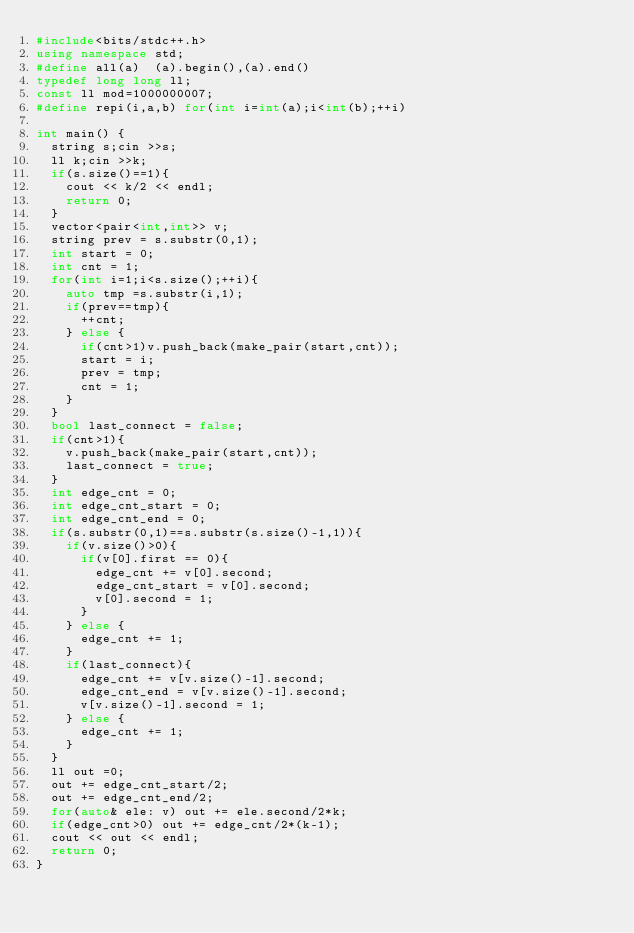<code> <loc_0><loc_0><loc_500><loc_500><_C++_>#include<bits/stdc++.h>
using namespace std;
#define all(a)  (a).begin(),(a).end()
typedef long long ll;
const ll mod=1000000007;
#define repi(i,a,b) for(int i=int(a);i<int(b);++i)

int main() {
  string s;cin >>s;
  ll k;cin >>k;
  if(s.size()==1){
    cout << k/2 << endl;
    return 0;
  }
  vector<pair<int,int>> v;
  string prev = s.substr(0,1);
  int start = 0;
  int cnt = 1;
  for(int i=1;i<s.size();++i){
    auto tmp =s.substr(i,1);
    if(prev==tmp){
      ++cnt;
    } else {
      if(cnt>1)v.push_back(make_pair(start,cnt));
      start = i;
      prev = tmp;
      cnt = 1;
    }
  }
  bool last_connect = false;
  if(cnt>1){
    v.push_back(make_pair(start,cnt));
    last_connect = true;
  }
  int edge_cnt = 0;
  int edge_cnt_start = 0;
  int edge_cnt_end = 0;
  if(s.substr(0,1)==s.substr(s.size()-1,1)){
    if(v.size()>0){
      if(v[0].first == 0){
        edge_cnt += v[0].second;
        edge_cnt_start = v[0].second;
        v[0].second = 1;
      }
    } else {
      edge_cnt += 1;
    }
    if(last_connect){
      edge_cnt += v[v.size()-1].second;
      edge_cnt_end = v[v.size()-1].second;
      v[v.size()-1].second = 1;
    } else {
      edge_cnt += 1;
    }
  }
  ll out =0;
  out += edge_cnt_start/2;
  out += edge_cnt_end/2;
  for(auto& ele: v) out += ele.second/2*k;
  if(edge_cnt>0) out += edge_cnt/2*(k-1);
  cout << out << endl;
  return 0;
}
</code> 